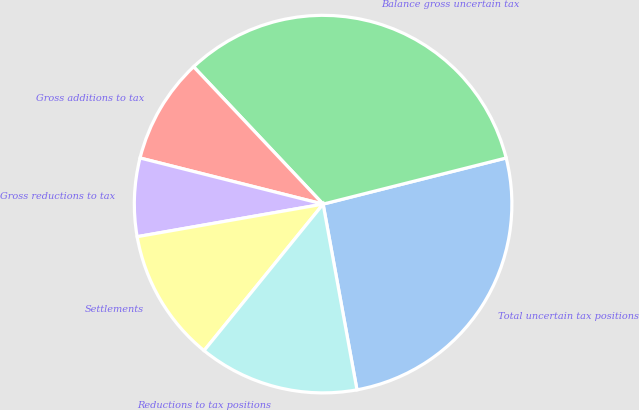Convert chart to OTSL. <chart><loc_0><loc_0><loc_500><loc_500><pie_chart><fcel>Total uncertain tax positions<fcel>Balance gross uncertain tax<fcel>Gross additions to tax<fcel>Gross reductions to tax<fcel>Settlements<fcel>Reductions to tax positions<nl><fcel>26.06%<fcel>33.1%<fcel>9.04%<fcel>6.69%<fcel>11.38%<fcel>13.73%<nl></chart> 